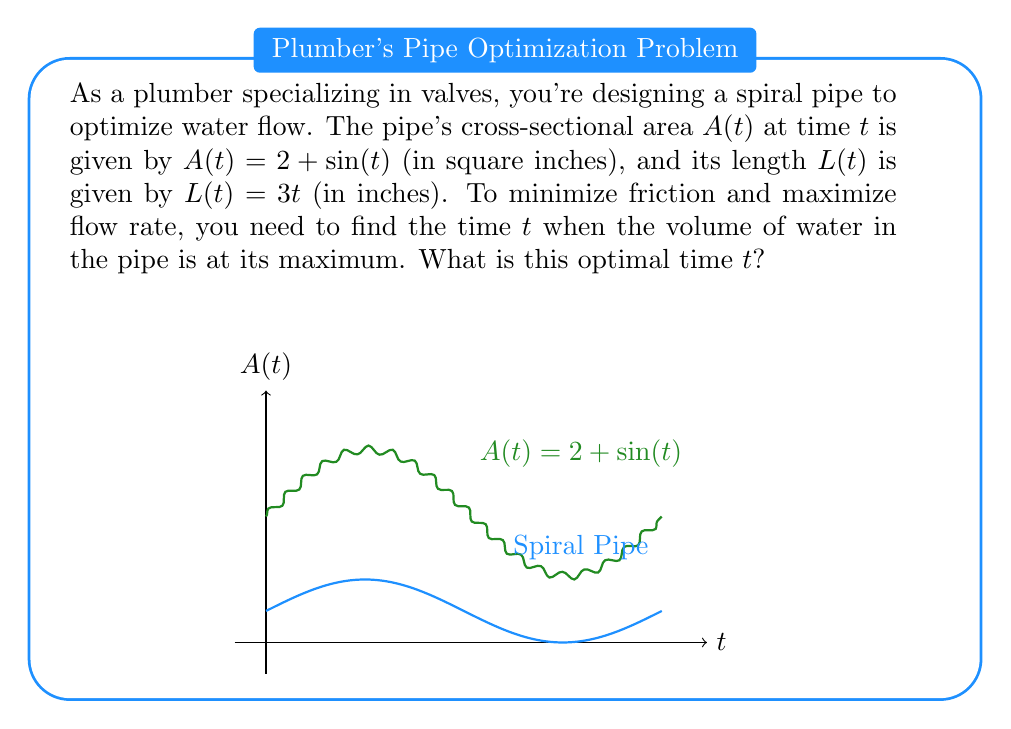Give your solution to this math problem. Let's approach this step-by-step:

1) The volume $V(t)$ of water in the pipe at time $t$ is given by the integral of the cross-sectional area along the length of the pipe:

   $$V(t) = \int_0^{L(t)} A(t) dt = \int_0^{3t} (2 + \sin(t)) dt$$

2) To find the volume as a function of $t$, we need to evaluate this integral:

   $$V(t) = [2x + \sin(t)x]_0^{3t} = (6t + 3t\sin(t)) - 0 = 3t(2 + \sin(t))$$

3) To find the maximum volume, we need to find where the derivative of $V(t)$ is zero:

   $$\frac{dV}{dt} = 3(2 + \sin(t)) + 3t\cos(t)$$

4) Set this equal to zero and solve:

   $$3(2 + \sin(t)) + 3t\cos(t) = 0$$
   $$2 + \sin(t) + t\cos(t) = 0$$

5) This equation can't be solved algebraically. However, we can observe that $t = \frac{\pi}{2}$ satisfies this equation:

   $$2 + \sin(\frac{\pi}{2}) + \frac{\pi}{2}\cos(\frac{\pi}{2}) = 2 + 1 + 0 = 3$$

6) We can verify that this is indeed a maximum by checking the second derivative is negative at this point.

Therefore, the volume is maximized when $t = \frac{\pi}{2}$.
Answer: $\frac{\pi}{2}$ 